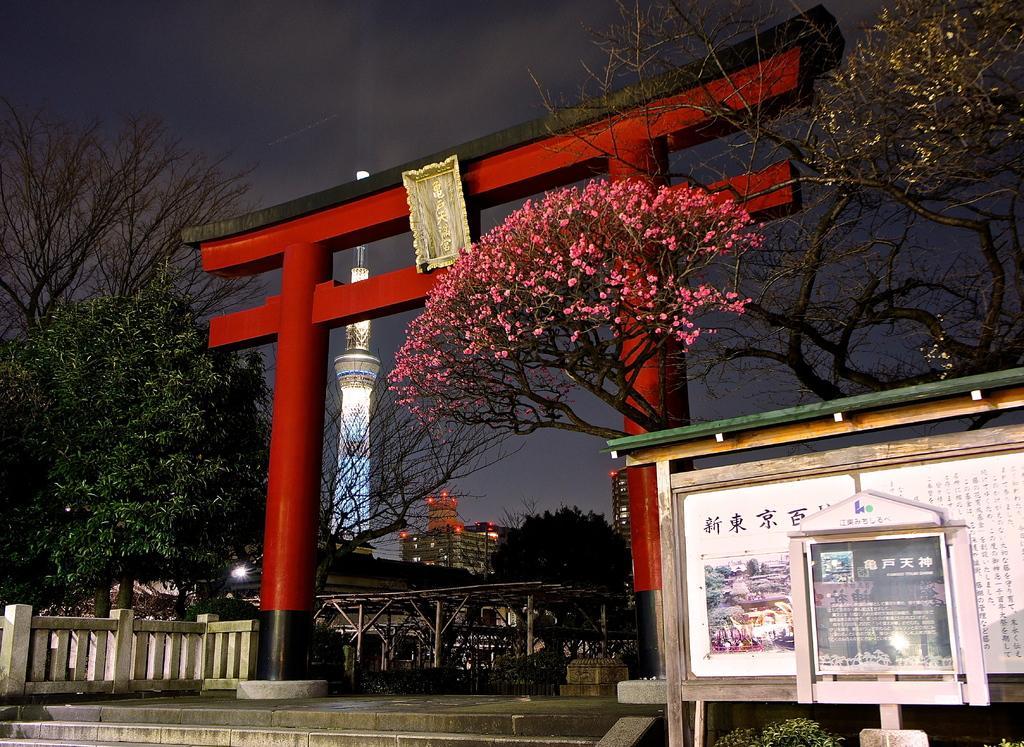Describe this image in one or two sentences. In this image I can see the board. To the side of the board I can see the red color arch, railing and many trees. I can see the pink color flowers to the tree. In the background I can see few more trees, tower and the buildings with lights. I can also see the sky in the back. 